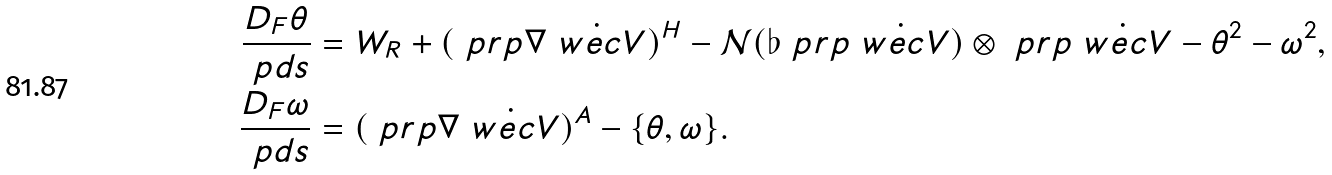<formula> <loc_0><loc_0><loc_500><loc_500>\frac { D _ { F } \theta } { \ p d s } & = W _ { R } + ( \ p r p \nabla \dot { \ w e c { V } } ) ^ { H } - \mathcal { N } ( \flat \ p r p \dot { \ w e c { V } } ) \otimes \ p r p \dot { \ w e c { V } } - \theta ^ { 2 } - \omega ^ { 2 } , \\ \frac { D _ { F } \omega } { \ p d s } & = ( \ p r p \nabla \dot { \ w e c { V } } ) ^ { A } - \{ \theta , \omega \} .</formula> 